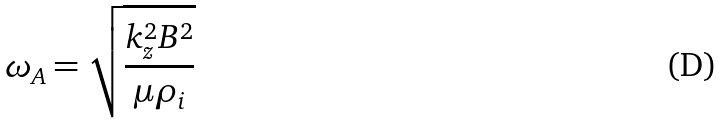Convert formula to latex. <formula><loc_0><loc_0><loc_500><loc_500>\omega _ { A } = \sqrt { \frac { k _ { z } ^ { 2 } B ^ { 2 } } { \mu \rho _ { i } } }</formula> 